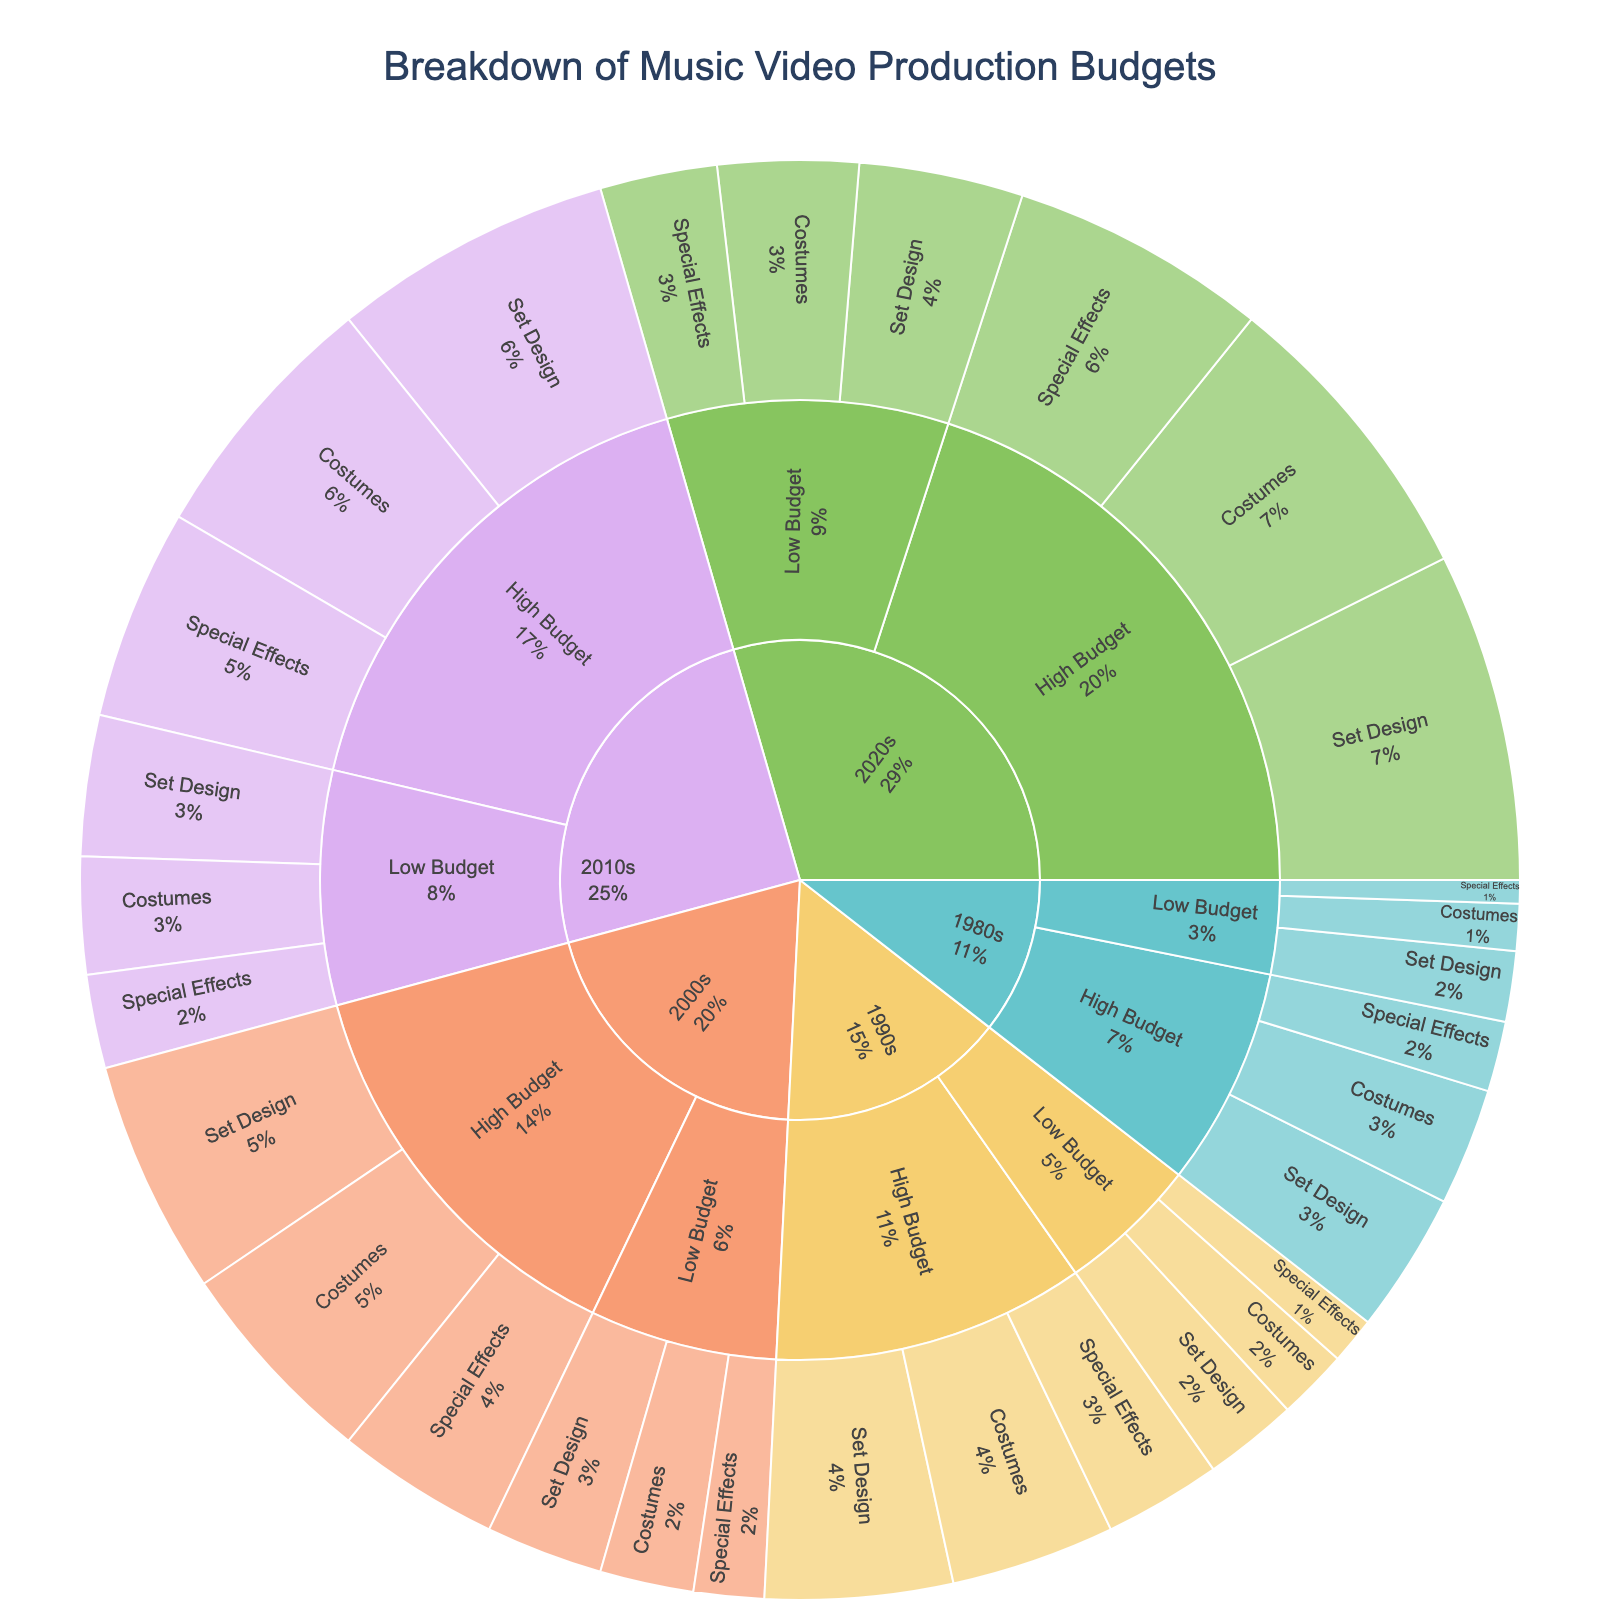What's the title of the plot? The title is shown at the top center of the plot.
Answer: Breakdown of Music Video Production Budgets Which era shows the highest overall budget value? By looking at the top-level sections of the sunburst plot, the 2020s have the largest segment, indicating the highest budget value.
Answer: 2020s How much was spent on Special Effects in high-budget music videos in the 2010s? Navigate to the section of the sunburst plot representing the 2010s, then to High Budget, and finally see the segment for Special Effects.
Answer: 45 What is the total budget for costumes in low-budget videos across all eras? Sum the values for Low Budget costumes across all eras: 10 (1980s) + 15 (1990s) + 20 (2000s) + 25 (2010s) + 30 (2020s) = 100.
Answer: 100 Which subcategory has the highest expenditure in the 1980s? Check all the subcategories in the 1980s. The largest segment among Set Design, Costumes, and Special Effects is for High Budget Set Design.
Answer: Set Design Compare the spending on Special Effects between the 2000s High Budget and 2020s Low Budget. Which is higher? Look at the values for Special Effects in these specific sections. 35 for High Budget 2000s and 25 for Low Budget 2020s. 35 is greater than 25.
Answer: High Budget 2000s What is the average budget for Set Design in Low Budget videos from the 1980s to the 2020s? Sum the Set Design values for Low Budget across all eras and then divide by the number of eras: (15 + 20 + 25 + 30 + 35) / 5 = 25.
Answer: 25 How much more was spent on High Budget Set Design in the 2020s compared to the 1980s? Subtract the value for High Budget Set Design in the 1980s from the value in the 2020s: 70 - 30 = 40.
Answer: 40 What proportion of the total 1990s budget is allocated to High Budget Special Effects? Calculate the total budget for the 1990s: 20 + 15 + 10 (Low Budget) + 40 + 35 + 25 (High Budget) = 145. The proportion for High Budget Special Effects is 25 / 145 ≈ 0.1724, or about 17.24%.
Answer: 17.24% 